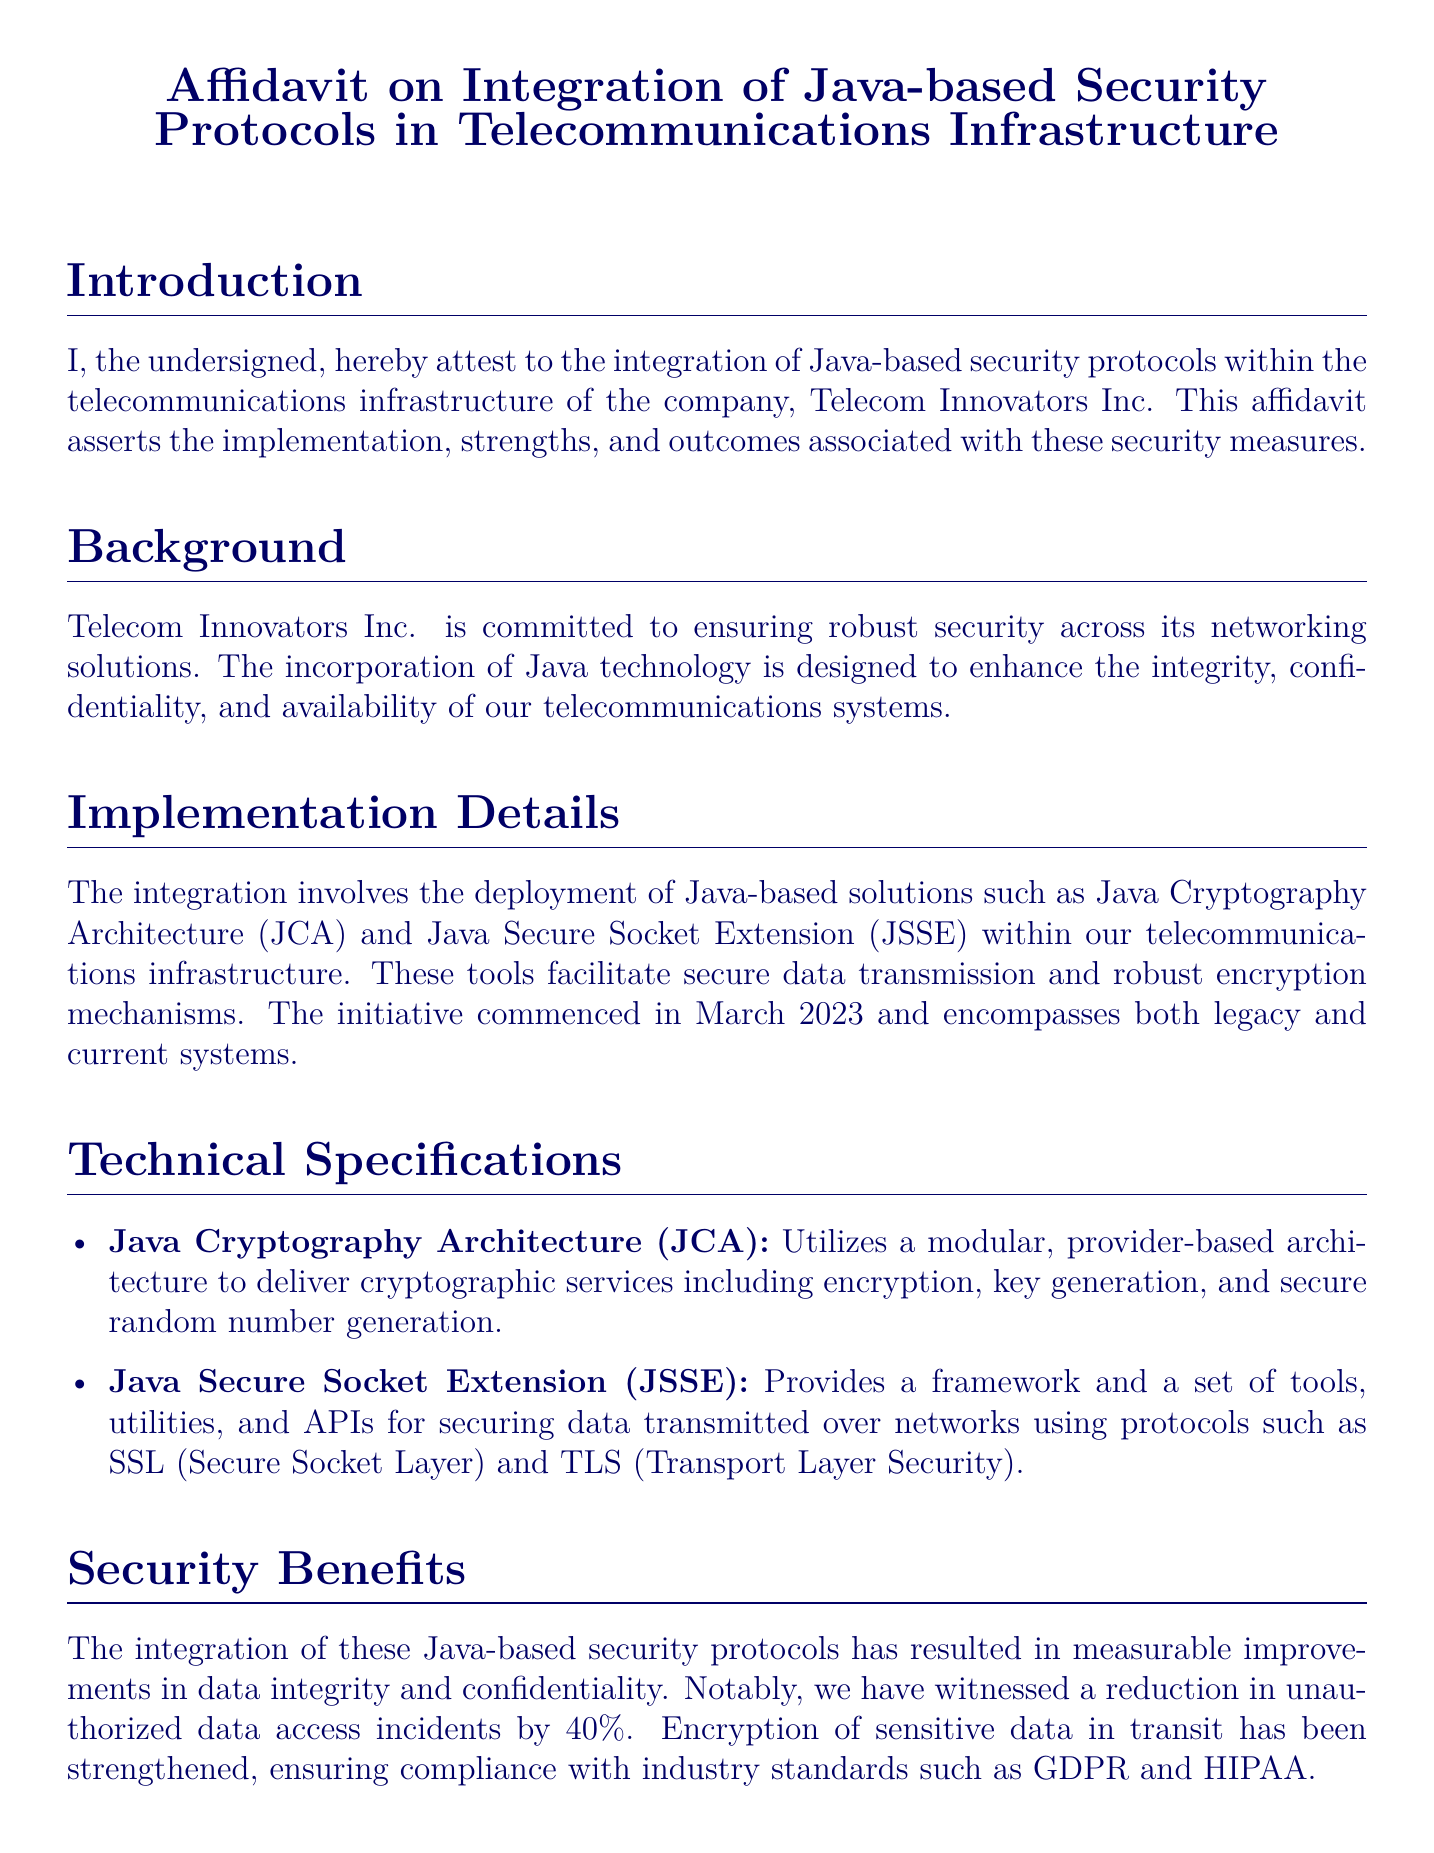What is the name of the company mentioned in the affidavit? The affidavit states the name of the company as Telecom Innovators Inc.
Answer: Telecom Innovators Inc When did the integration initiative commence? The document specifies that the initiative began in March 2023.
Answer: March 2023 What security protocol is abbreviated as JCA? The document explains that JCA stands for Java Cryptography Architecture.
Answer: Java Cryptography Architecture What percentage reduction in unauthorized data access incidents was reported? It is cited in the document that there has been a 40% reduction in unauthorized data access incidents.
Answer: 40% Which international security standard is mentioned for information security management? The affidavit mentions ISO/IEC 27001 as an international security standard.
Answer: ISO/IEC 27001 What is the framework provided by JSSE used for? JSSE is described as providing a framework for securing data transmitted over networks using SSL and TLS.
Answer: Securing data transmitted over networks What is the primary purpose of Java-based security protocols according to the document? The document summarizes their main purpose as enhancing integrity, confidentiality, and availability in telecommunications systems.
Answer: Enhancing integrity, confidentiality, and availability Who affirms the statements in this document? The affidavit states that the signer affirms the truthfulness and accuracy of the statements made.
Answer: The signer What industry standards are mentioned with which compliance has been ensured? The document mentions compliance with GDPR and HIPAA.
Answer: GDPR and HIPAA 